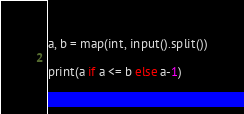<code> <loc_0><loc_0><loc_500><loc_500><_Python_>a, b = map(int, input().split())

print(a if a <= b else a-1)</code> 